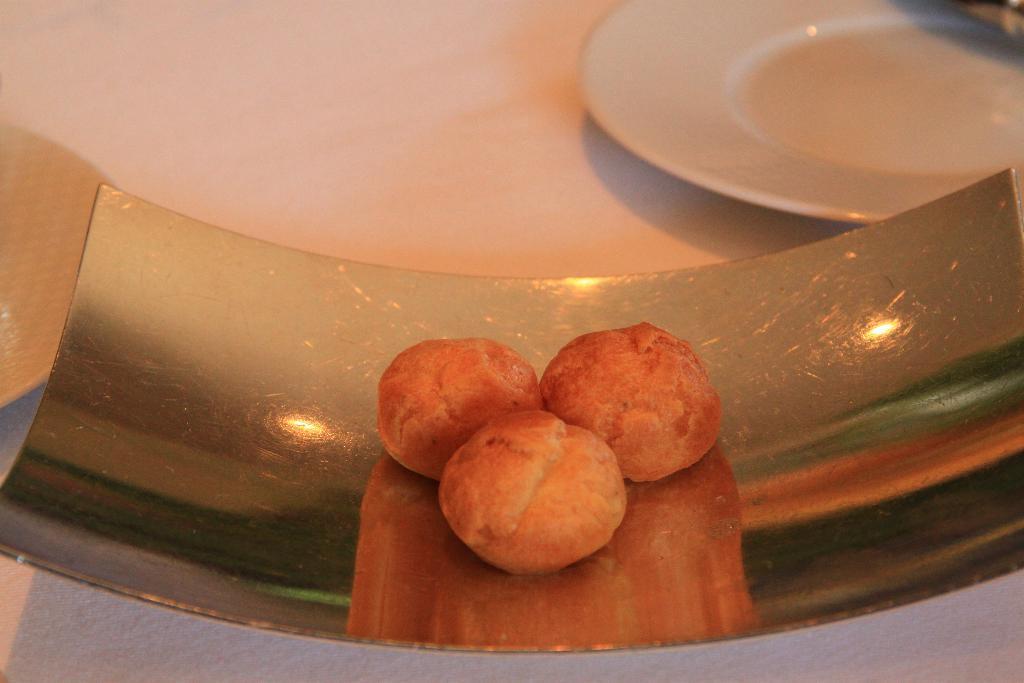Please provide a concise description of this image. In the picture we can see a food item on the tray and beside it, we can see a plate which is white in color. 